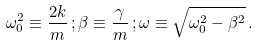Convert formula to latex. <formula><loc_0><loc_0><loc_500><loc_500>\omega _ { 0 } ^ { 2 } \equiv \frac { 2 k } { m } \, ; \beta \equiv \frac { \gamma } { m } \, ; \omega \equiv \sqrt { \omega _ { 0 } ^ { 2 } - \beta ^ { 2 } } \, .</formula> 